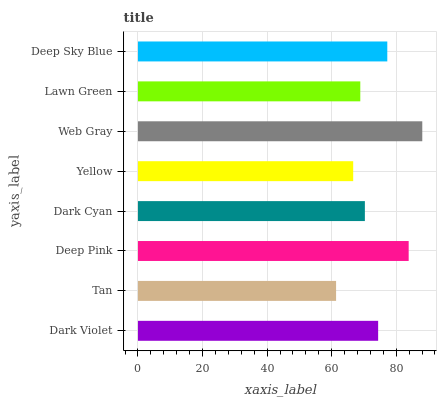Is Tan the minimum?
Answer yes or no. Yes. Is Web Gray the maximum?
Answer yes or no. Yes. Is Deep Pink the minimum?
Answer yes or no. No. Is Deep Pink the maximum?
Answer yes or no. No. Is Deep Pink greater than Tan?
Answer yes or no. Yes. Is Tan less than Deep Pink?
Answer yes or no. Yes. Is Tan greater than Deep Pink?
Answer yes or no. No. Is Deep Pink less than Tan?
Answer yes or no. No. Is Dark Violet the high median?
Answer yes or no. Yes. Is Dark Cyan the low median?
Answer yes or no. Yes. Is Deep Sky Blue the high median?
Answer yes or no. No. Is Tan the low median?
Answer yes or no. No. 